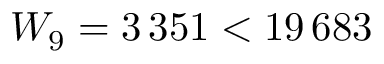Convert formula to latex. <formula><loc_0><loc_0><loc_500><loc_500>W _ { 9 } = 3 \, 3 5 1 < 1 9 \, 6 8 3</formula> 